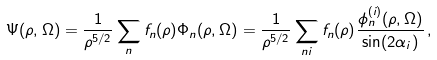<formula> <loc_0><loc_0><loc_500><loc_500>\Psi ( \rho , \Omega ) = \frac { 1 } { \rho ^ { 5 / 2 } } \sum _ { n } f _ { n } ( \rho ) \Phi _ { n } ( \rho , \Omega ) = \frac { 1 } { \rho ^ { 5 / 2 } } \sum _ { n i } f _ { n } ( \rho ) \frac { \phi _ { n } ^ { ( i ) } ( \rho , \Omega ) } { \sin ( 2 \alpha _ { i } ) } \, ,</formula> 